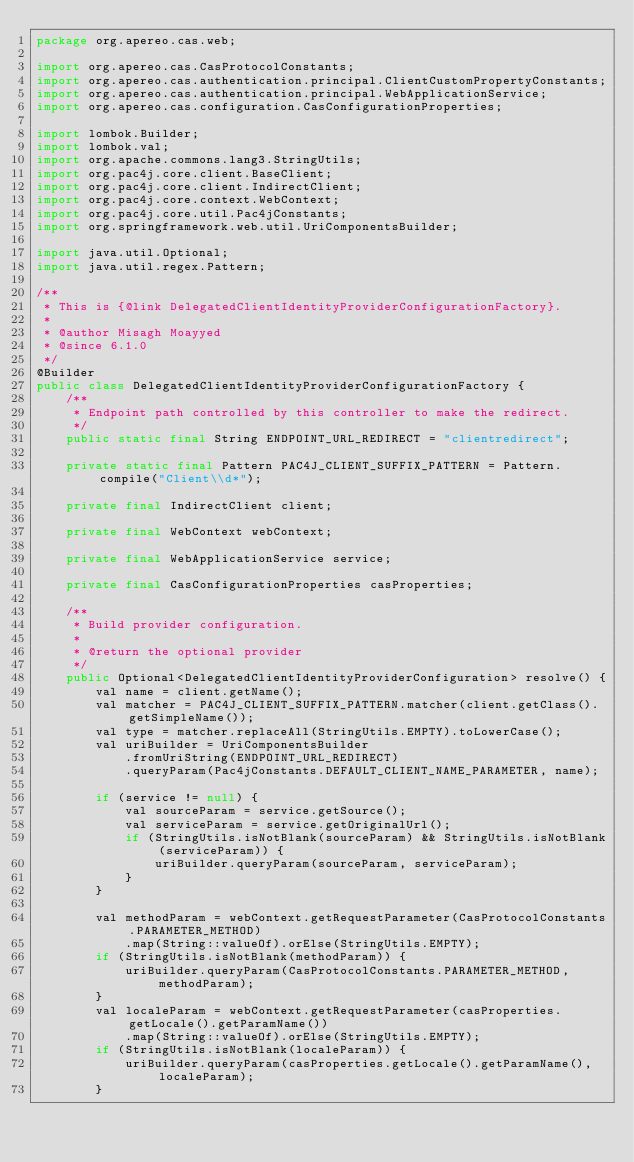Convert code to text. <code><loc_0><loc_0><loc_500><loc_500><_Java_>package org.apereo.cas.web;

import org.apereo.cas.CasProtocolConstants;
import org.apereo.cas.authentication.principal.ClientCustomPropertyConstants;
import org.apereo.cas.authentication.principal.WebApplicationService;
import org.apereo.cas.configuration.CasConfigurationProperties;

import lombok.Builder;
import lombok.val;
import org.apache.commons.lang3.StringUtils;
import org.pac4j.core.client.BaseClient;
import org.pac4j.core.client.IndirectClient;
import org.pac4j.core.context.WebContext;
import org.pac4j.core.util.Pac4jConstants;
import org.springframework.web.util.UriComponentsBuilder;

import java.util.Optional;
import java.util.regex.Pattern;

/**
 * This is {@link DelegatedClientIdentityProviderConfigurationFactory}.
 *
 * @author Misagh Moayyed
 * @since 6.1.0
 */
@Builder
public class DelegatedClientIdentityProviderConfigurationFactory {
    /**
     * Endpoint path controlled by this controller to make the redirect.
     */
    public static final String ENDPOINT_URL_REDIRECT = "clientredirect";

    private static final Pattern PAC4J_CLIENT_SUFFIX_PATTERN = Pattern.compile("Client\\d*");

    private final IndirectClient client;

    private final WebContext webContext;

    private final WebApplicationService service;

    private final CasConfigurationProperties casProperties;

    /**
     * Build provider configuration.
     *
     * @return the optional provider
     */
    public Optional<DelegatedClientIdentityProviderConfiguration> resolve() {
        val name = client.getName();
        val matcher = PAC4J_CLIENT_SUFFIX_PATTERN.matcher(client.getClass().getSimpleName());
        val type = matcher.replaceAll(StringUtils.EMPTY).toLowerCase();
        val uriBuilder = UriComponentsBuilder
            .fromUriString(ENDPOINT_URL_REDIRECT)
            .queryParam(Pac4jConstants.DEFAULT_CLIENT_NAME_PARAMETER, name);

        if (service != null) {
            val sourceParam = service.getSource();
            val serviceParam = service.getOriginalUrl();
            if (StringUtils.isNotBlank(sourceParam) && StringUtils.isNotBlank(serviceParam)) {
                uriBuilder.queryParam(sourceParam, serviceParam);
            }
        }

        val methodParam = webContext.getRequestParameter(CasProtocolConstants.PARAMETER_METHOD)
            .map(String::valueOf).orElse(StringUtils.EMPTY);
        if (StringUtils.isNotBlank(methodParam)) {
            uriBuilder.queryParam(CasProtocolConstants.PARAMETER_METHOD, methodParam);
        }
        val localeParam = webContext.getRequestParameter(casProperties.getLocale().getParamName())
            .map(String::valueOf).orElse(StringUtils.EMPTY);
        if (StringUtils.isNotBlank(localeParam)) {
            uriBuilder.queryParam(casProperties.getLocale().getParamName(), localeParam);
        }</code> 